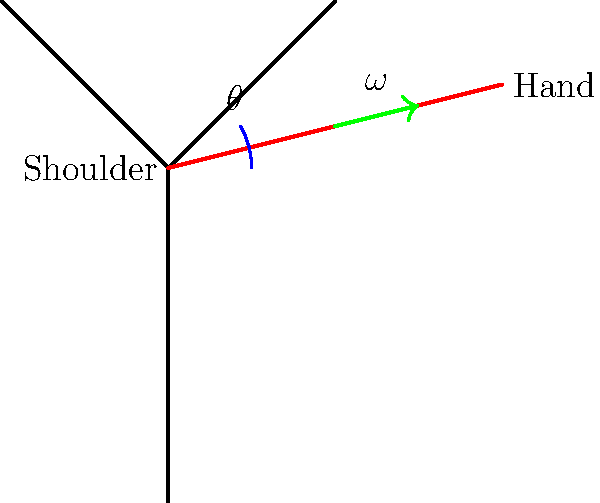In a traditional Bharatanatyam pose, a dancer's arm moves from a resting position to an extended position in 0.5 seconds, covering an angle of 30°. What is the average angular velocity of the dancer's arm during this movement? To calculate the average angular velocity of the dancer's arm, we need to follow these steps:

1. Understand the given information:
   - Initial angle: 0° (resting position)
   - Final angle: 30° (extended position)
   - Time taken: 0.5 seconds

2. Recall the formula for average angular velocity:
   $$\omega = \frac{\Delta \theta}{\Delta t}$$
   where $\omega$ is the angular velocity, $\Delta \theta$ is the change in angle, and $\Delta t$ is the change in time.

3. Calculate the change in angle:
   $\Delta \theta = 30° - 0° = 30°$

4. Convert the angle from degrees to radians:
   $$30° \times \frac{\pi}{180°} = \frac{\pi}{6} \text{ radians}$$

5. Apply the formula:
   $$\omega = \frac{\frac{\pi}{6} \text{ radians}}{0.5 \text{ seconds}}$$

6. Simplify:
   $$\omega = \frac{\pi}{3} \text{ radians/second}$$

Therefore, the average angular velocity of the dancer's arm during this Bharatanatyam pose is $\frac{\pi}{3}$ radians per second.
Answer: $\frac{\pi}{3}$ rad/s 